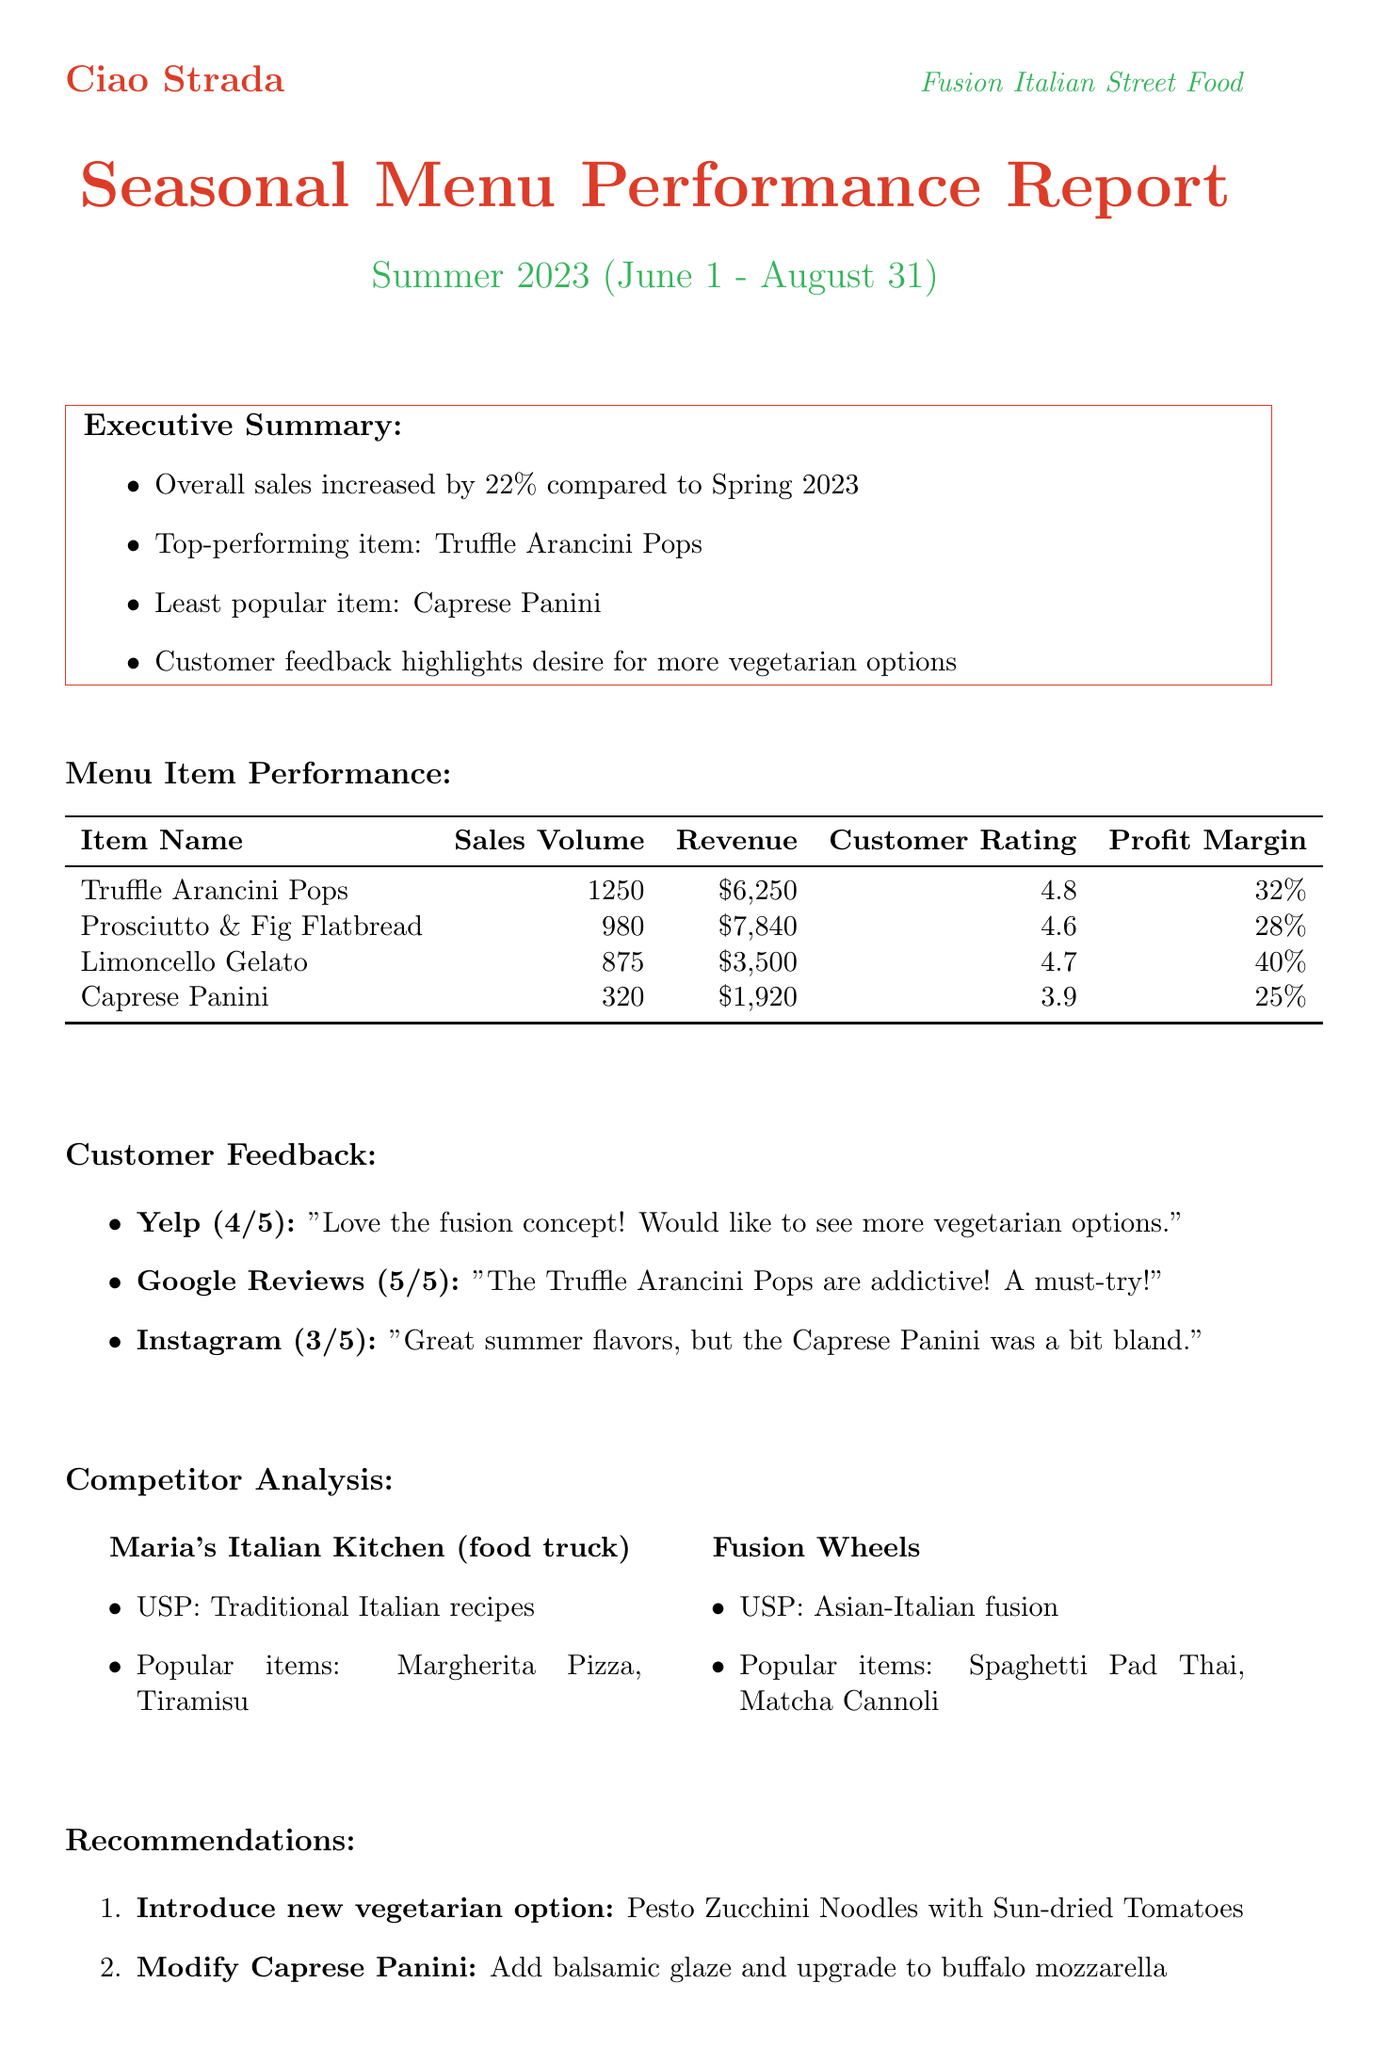What was the overall sales increase? The overall sales increase is noted in the executive summary as a percentage increase compared to Spring 2023.
Answer: 22% What is the top-performing menu item? The report identifies the top-performing item in the executive summary.
Answer: Truffle Arancini Pops How many Caprese Panini were sold? The sales volume for the Caprese Panini is listed in the menu item performance section.
Answer: 320 What is the customer rating for Limoncello Gelato? The customer rating for Limoncello Gelato is provided in the menu item performance section.
Answer: 4.7 What recommendation is made for the Caprese Panini? The report suggests an action to modify the Caprese Panini in the recommendations section.
Answer: Add balsamic glaze and upgrade to buffalo mozzarella Which local event could impact the menu? The report highlights a local event that may influence the business.
Answer: Little Italy Food Festival What unique selling point does Maria's Italian Kitchen have? The competitor analysis includes a unique selling point for Maria's Italian Kitchen.
Answer: Traditional Italian recipes Name one upcoming food trend mentioned. The report discusses future menu considerations, including trends in food.
Answer: Plant-based proteins 